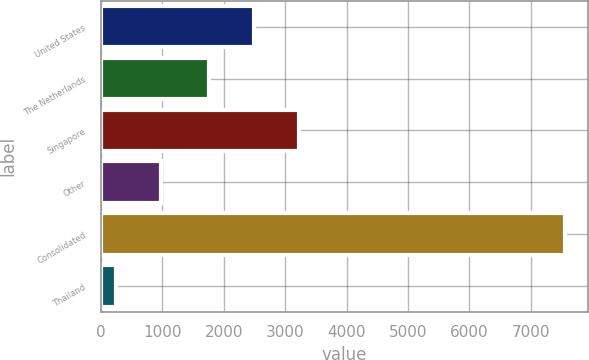<chart> <loc_0><loc_0><loc_500><loc_500><bar_chart><fcel>United States<fcel>The Netherlands<fcel>Singapore<fcel>Other<fcel>Consolidated<fcel>Thailand<nl><fcel>2498<fcel>1767<fcel>3229<fcel>974<fcel>7553<fcel>243<nl></chart> 